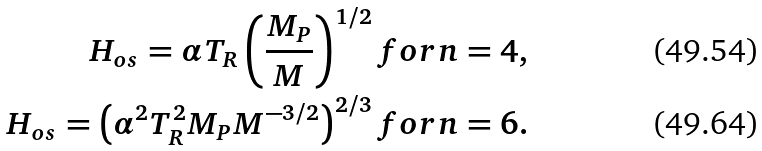Convert formula to latex. <formula><loc_0><loc_0><loc_500><loc_500>H _ { o s } = \alpha T _ { R } \left ( \frac { M _ { P } } { M } \right ) ^ { 1 / 2 } f o r n = 4 , \\ H _ { o s } = \left ( \alpha ^ { 2 } T _ { R } ^ { 2 } M _ { P } M ^ { - 3 / 2 } \right ) ^ { 2 / 3 } f o r n = 6 .</formula> 